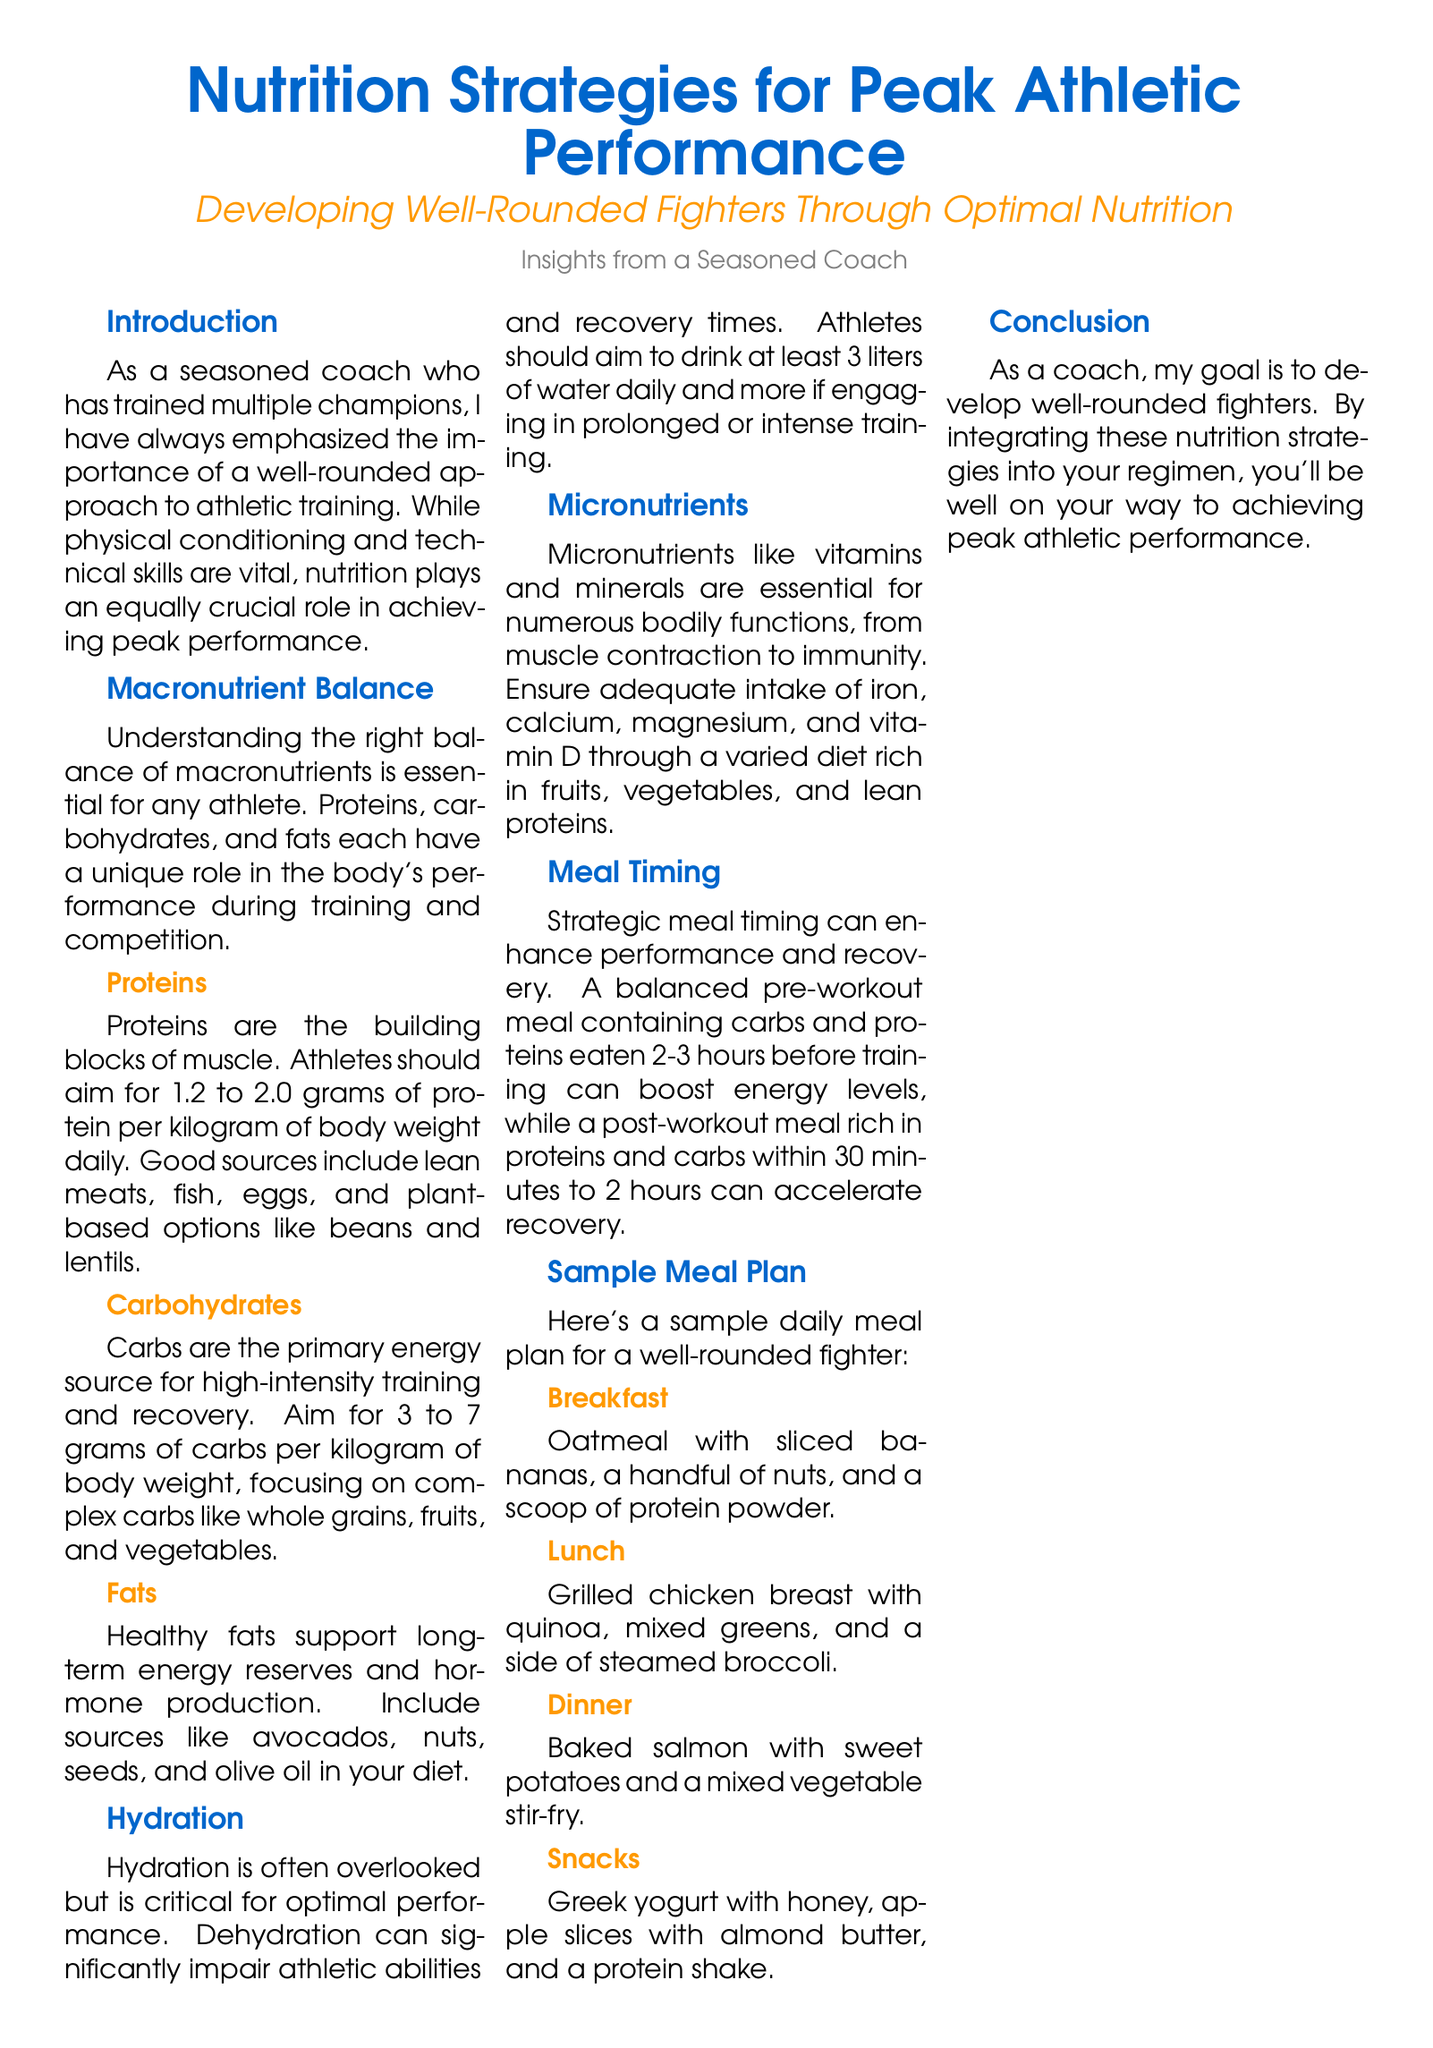What is emphasized as equally crucial in achieving peak performance? The document states that nutrition plays an equally crucial role alongside physical conditioning and technical skills in achieving peak performance.
Answer: Nutrition What is the recommended protein intake for athletes per kilogram of body weight? The document specifies that athletes should aim for 1.2 to 2.0 grams of protein per kilogram of body weight daily.
Answer: 1.2 to 2.0 grams What are the recommended daily water intake levels for athletes? The document mentions that athletes should aim to drink at least 3 liters of water daily and more if engaging in prolonged or intense training.
Answer: At least 3 liters How many grams of carbohydrates should athletes aim for per kilogram of body weight? The document states that athletes should aim for 3 to 7 grams of carbs per kilogram of body weight.
Answer: 3 to 7 grams What type of meal is suggested for post-workout recovery? The document suggests a post-workout meal rich in proteins and carbs within 30 minutes to 2 hours.
Answer: Rich in proteins and carbs What is included in the breakfast sample meal? The document lists oatmeal with sliced bananas, a handful of nuts, and a scoop of protein powder as the breakfast sample meal.
Answer: Oatmeal with sliced bananas, nuts, and protein powder Name one source of healthy fats mentioned in the document. The document includes avocados, nuts, seeds, and olive oil as sources of healthy fats.
Answer: Avocados What does the quote in the document emphasize about diet? The quote emphasizes that a balanced diet is key to peak athletic performance.
Answer: A balanced diet is key to peak athletic performance What is the primary focus of the article? The article focuses on nutrition strategies for peak athletic performance.
Answer: Nutrition strategies for peak athletic performance 